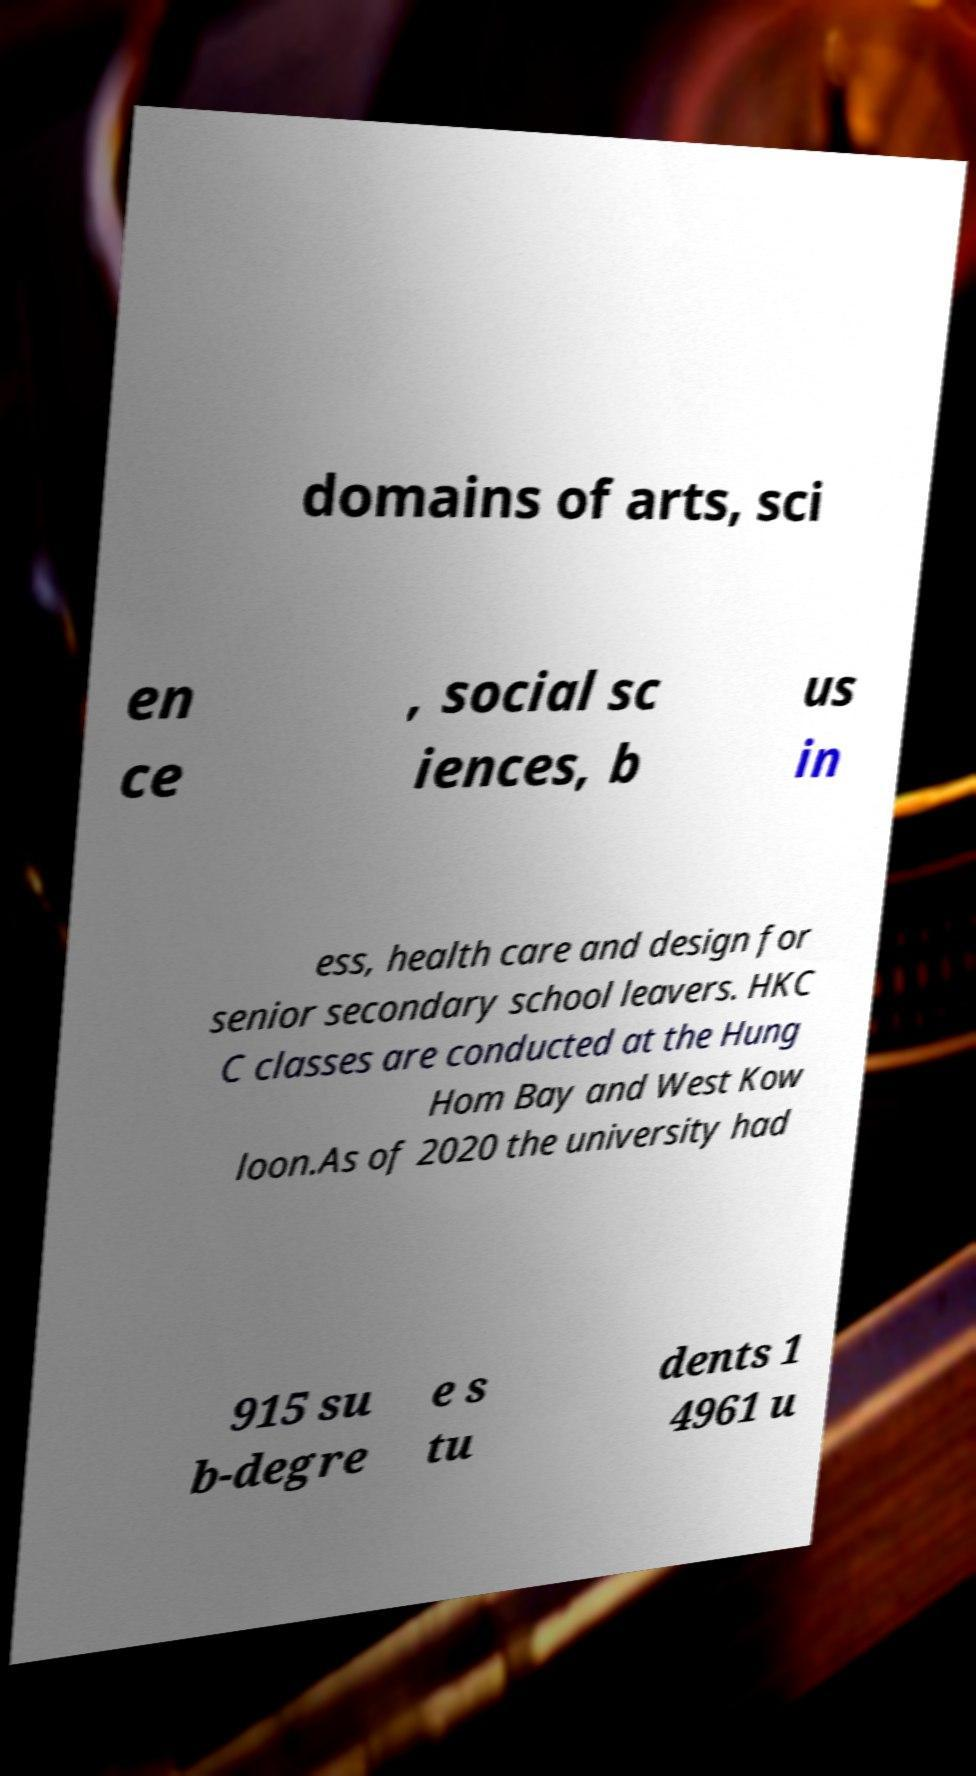Can you read and provide the text displayed in the image?This photo seems to have some interesting text. Can you extract and type it out for me? domains of arts, sci en ce , social sc iences, b us in ess, health care and design for senior secondary school leavers. HKC C classes are conducted at the Hung Hom Bay and West Kow loon.As of 2020 the university had 915 su b-degre e s tu dents 1 4961 u 